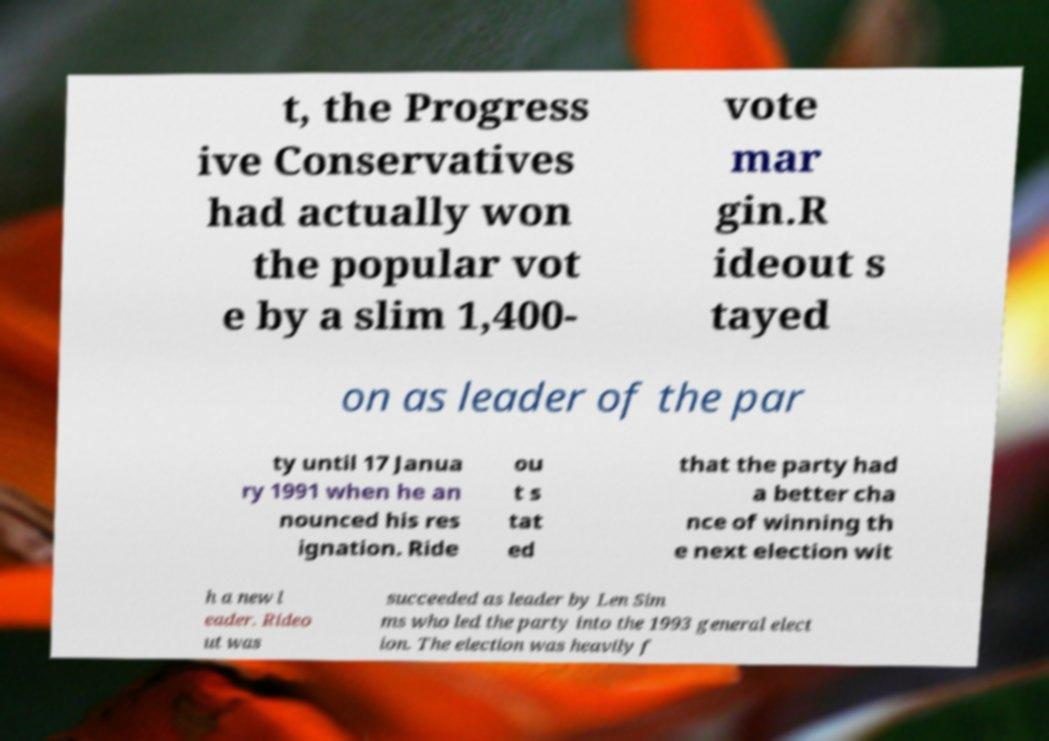Please identify and transcribe the text found in this image. t, the Progress ive Conservatives had actually won the popular vot e by a slim 1,400- vote mar gin.R ideout s tayed on as leader of the par ty until 17 Janua ry 1991 when he an nounced his res ignation. Ride ou t s tat ed that the party had a better cha nce of winning th e next election wit h a new l eader. Rideo ut was succeeded as leader by Len Sim ms who led the party into the 1993 general elect ion. The election was heavily f 